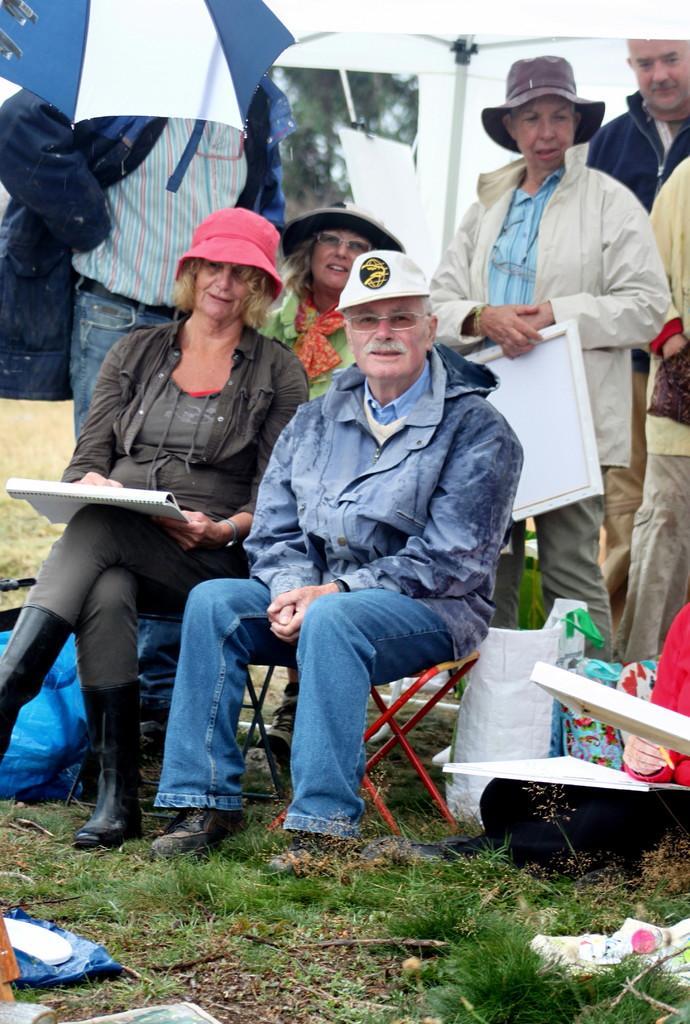In one or two sentences, can you explain what this image depicts? In this picture there are two persons sitting and there are few persons standing behind behind them. 